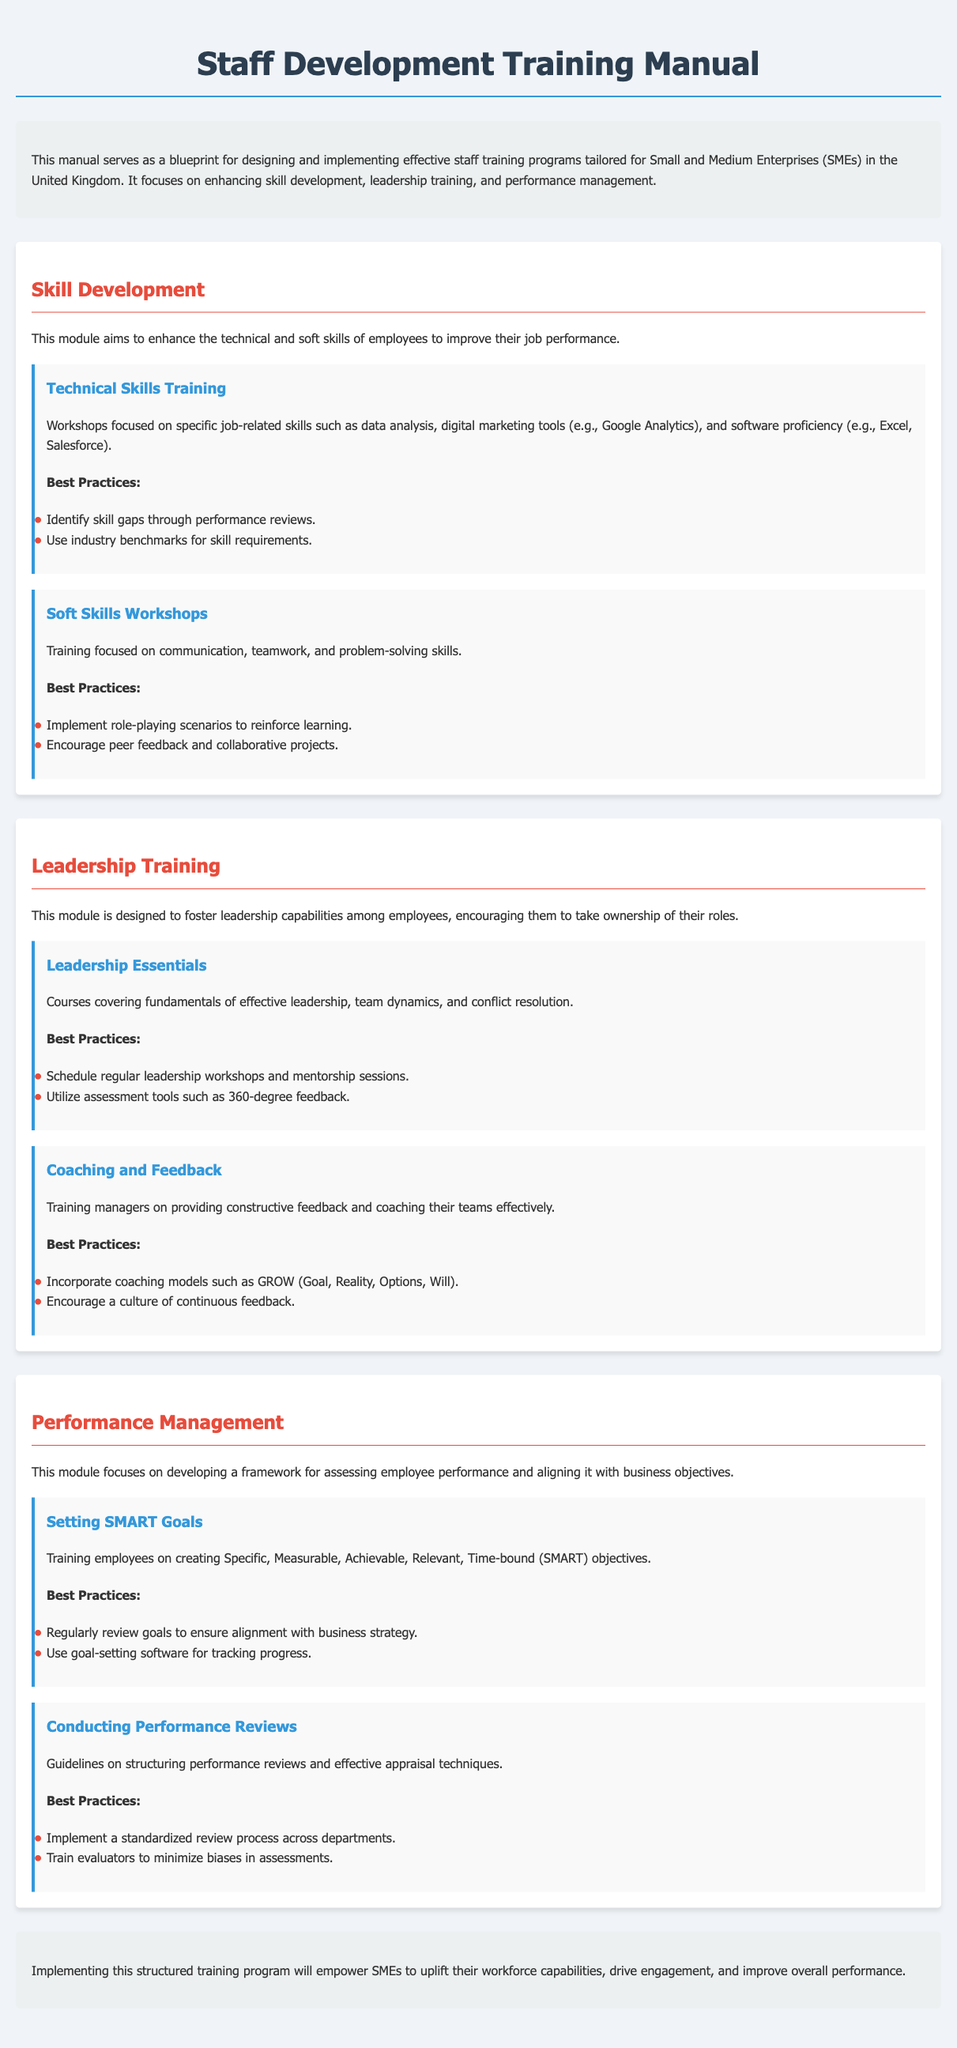what is the focus of the manual? The manual focuses on enhancing skill development, leadership training, and performance management for SMEs in the UK.
Answer: enhancing skill development, leadership training, and performance management what is the first module in the document? The first module outlined in the document is the Skill Development module.
Answer: Skill Development how many components are in the Leadership Training module? The Leadership Training module contains two components, Leadership Essentials and Coaching and Feedback.
Answer: two what type of training does the Technical Skills Training component focus on? The Technical Skills Training component focuses on job-related skills such as data analysis and software proficiency.
Answer: job-related skills what framework is suggested for setting goals? The document recommends using the SMART framework for setting goals.
Answer: SMART what does the abbreviation SMART stand for? SMART stands for Specific, Measurable, Achievable, Relevant, Time-bound.
Answer: Specific, Measurable, Achievable, Relevant, Time-bound what is the main purpose of performance management according to the manual? The main purpose of performance management is to develop a framework for assessing employee performance and aligning it with business objectives.
Answer: assessing employee performance and aligning it with business objectives what is one of the best practices for Technical Skills Training? One of the best practices is to identify skill gaps through performance reviews.
Answer: identify skill gaps through performance reviews what is emphasized in the Soft Skills Workshops? The Soft Skills Workshops emphasize communication, teamwork, and problem-solving skills.
Answer: communication, teamwork, and problem-solving skills 